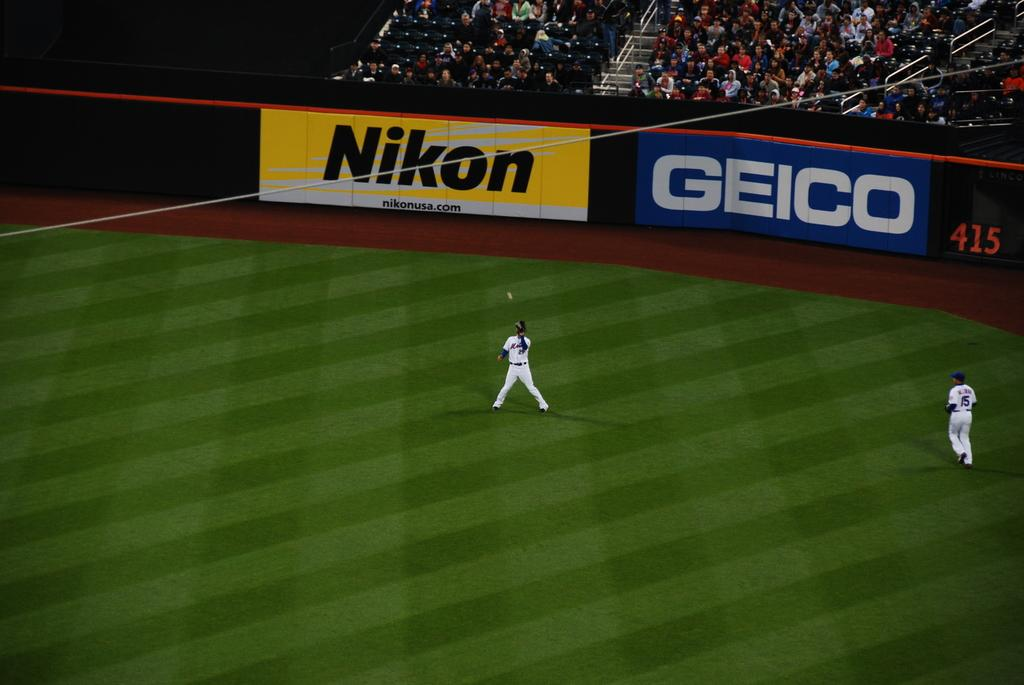<image>
Relay a brief, clear account of the picture shown. A wide shot of a baseball field with the sponsers Nikon and Geico in the background 